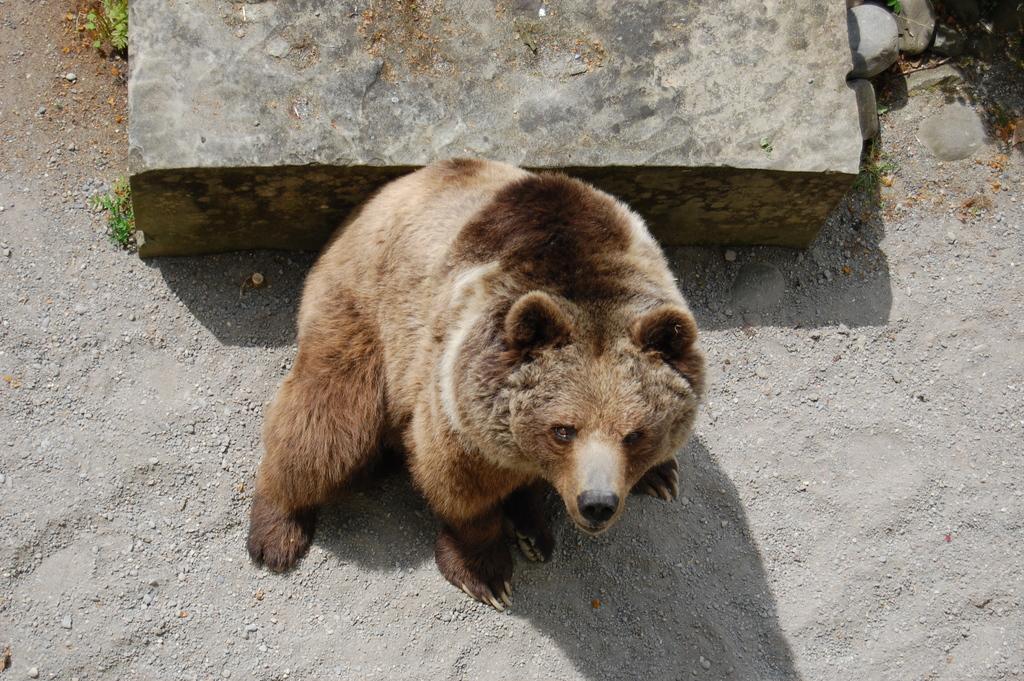In one or two sentences, can you explain what this image depicts? In this image we can see an animal. There are few plants at the left side of the image. There are few stones in the image. 